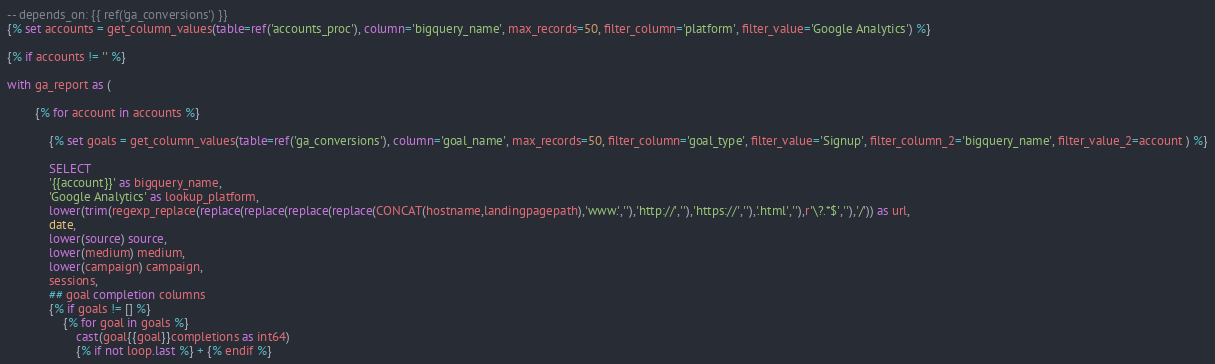Convert code to text. <code><loc_0><loc_0><loc_500><loc_500><_SQL_>-- depends_on: {{ ref('ga_conversions') }}
{% set accounts = get_column_values(table=ref('accounts_proc'), column='bigquery_name', max_records=50, filter_column='platform', filter_value='Google Analytics') %}

{% if accounts != '' %}

with ga_report as (

	    {% for account in accounts %}

	    	{% set goals = get_column_values(table=ref('ga_conversions'), column='goal_name', max_records=50, filter_column='goal_type', filter_value='Signup', filter_column_2='bigquery_name', filter_value_2=account ) %}
	    	
		   	SELECT
		   	'{{account}}' as bigquery_name,
		   	'Google Analytics' as lookup_platform,
			lower(trim(regexp_replace(replace(replace(replace(replace(CONCAT(hostname,landingpagepath),'www.',''),'http://',''),'https://',''),'.html',''),r'\?.*$',''),'/')) as url,
			date,
			lower(source) source,
			lower(medium) medium,
			lower(campaign) campaign,
			sessions,
			## goal completion columns
			{% if goals != [] %}
				{% for goal in goals %}
					cast(goal{{goal}}completions as int64) 
					{% if not loop.last %} + {% endif %} </code> 